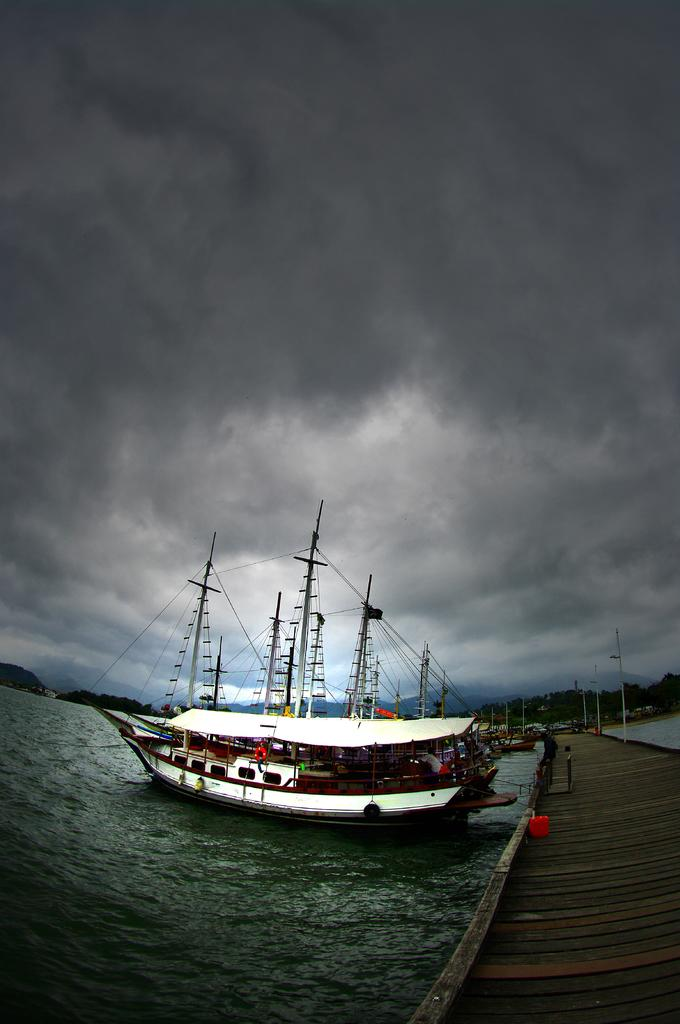What type of structure can be seen in the image? There are docks in the image. What is on the water near the docks? There are boats on the water in the image. What large body of water is visible in the image? There is an ocean visible in the image. What can be seen in the sky in the image? Clouds are present in the sky in the image. What type of advertisement can be seen on the boats in the image? There are no advertisements visible on the boats in the image; they are simply boats on the water. Are there any signs of pain or discomfort in the image? There is no indication of pain or discomfort in the image; it features docks, boats, an ocean, and clouds. 